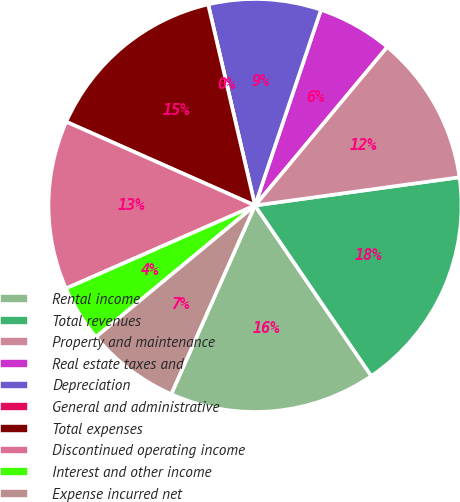<chart> <loc_0><loc_0><loc_500><loc_500><pie_chart><fcel>Rental income<fcel>Total revenues<fcel>Property and maintenance<fcel>Real estate taxes and<fcel>Depreciation<fcel>General and administrative<fcel>Total expenses<fcel>Discontinued operating income<fcel>Interest and other income<fcel>Expense incurred net<nl><fcel>16.18%<fcel>17.65%<fcel>11.76%<fcel>5.88%<fcel>8.82%<fcel>0.0%<fcel>14.71%<fcel>13.23%<fcel>4.41%<fcel>7.35%<nl></chart> 